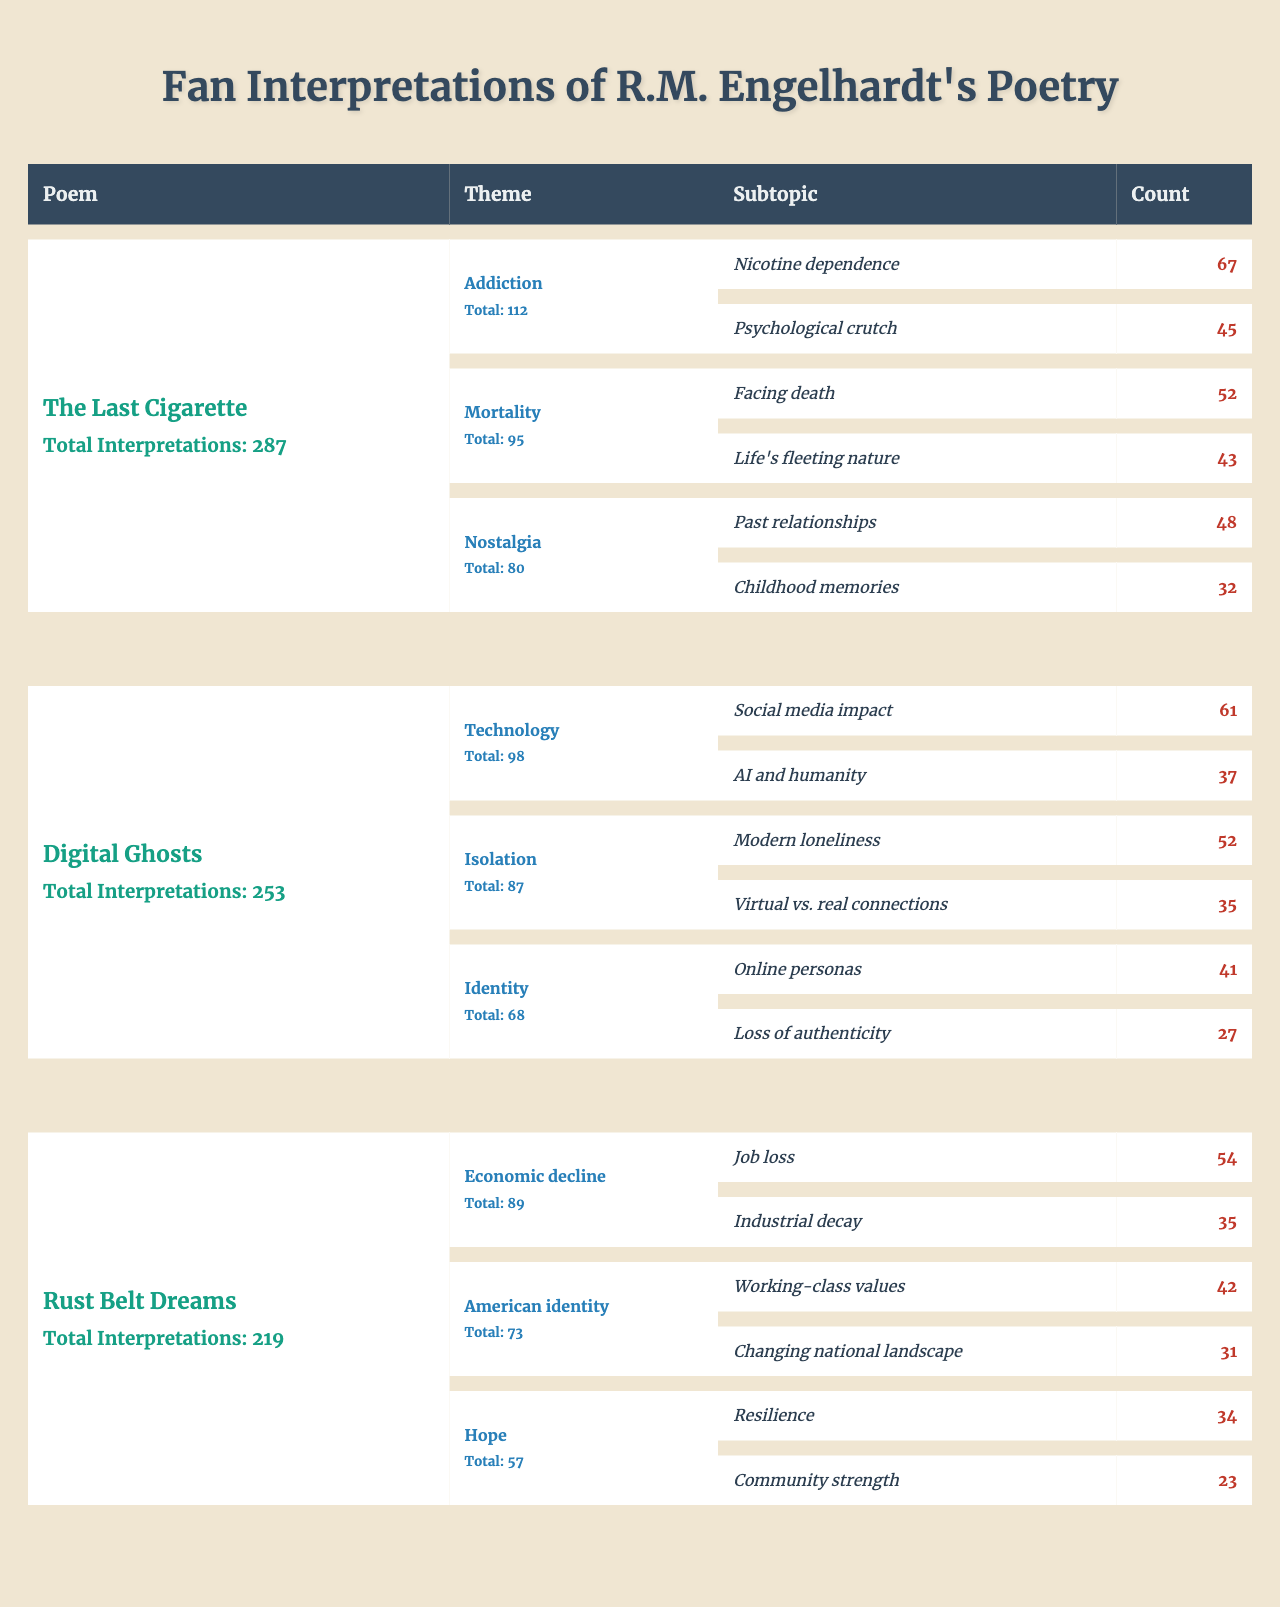What is the total number of interpretations for "The Last Cigarette"? The table shows that "The Last Cigarette" has a total of 287 interpretations listed under the "Total Interpretations" column.
Answer: 287 Which theme in "Digital Ghosts" has the highest count? In the table under "Digital Ghosts," the theme "Technology" has the highest count with 98, while the other themes have lower counts.
Answer: Technology How many subtopics are related to the theme of "Addiction" in "The Last Cigarette"? The theme "Addiction" for "The Last Cigarette" has two subtopics: "Nicotine dependence" and "Psychological crutch."
Answer: 2 What is the combined count of subtopics under the theme of "Mortality" for "The Last Cigarette"? The theme "Mortality" has two subtopics: "Facing death" (52) and "Life's fleeting nature" (43). Summing these counts gives 52 + 43 = 95.
Answer: 95 Is "Isolation" a theme explored in "Rust Belt Dreams"? The table indicates that "Isolation" is not listed as a theme under "Rust Belt Dreams," suggesting it is not explored in this poem.
Answer: No What is the average number of interpretations for all three poems? The total number of interpretations for the poems are: "The Last Cigarette" (287), "Digital Ghosts" (253), and "Rust Belt Dreams" (219). Summing these gives 287 + 253 + 219 = 759, and averaging across three poems results in 759 / 3 = 253.
Answer: 253 How many subtopics in "Digital Ghosts" categorize under "Social media impact"? The subtopic "Social media impact" is categorized under the theme "Technology" and has a count of 61 as indicated in the table.
Answer: 61 Which poem has the least total interpretations? Comparing the total interpretations, "Rust Belt Dreams" has 219, which is the lowest compared to the other poems.
Answer: Rust Belt Dreams What themes and their counts are there in "Rust Belt Dreams"? In "Rust Belt Dreams," three themes are listed: Economic decline (89), American identity (73), and Hope (57), with their respective counts.
Answer: Economic decline (89), American identity (73), Hope (57) What is the count of the subtopic "Online personas" in "Digital Ghosts"? The subtopic "Online personas" is under the theme "Identity" and has a count of 41 based on the table.
Answer: 41 How does the count of subtopics in "Nostalgia" compare to that in "Hope" from "Rust Belt Dreams"? "Nostalgia" in "The Last Cigarette" has two subtopics (80 total), while "Hope" in "Rust Belt Dreams" has two subtopics (57 total). Since both have two subtopics, the comparison indicates that "Nostalgia" has a higher overall count.
Answer: Nostalgia is greater than Hope 